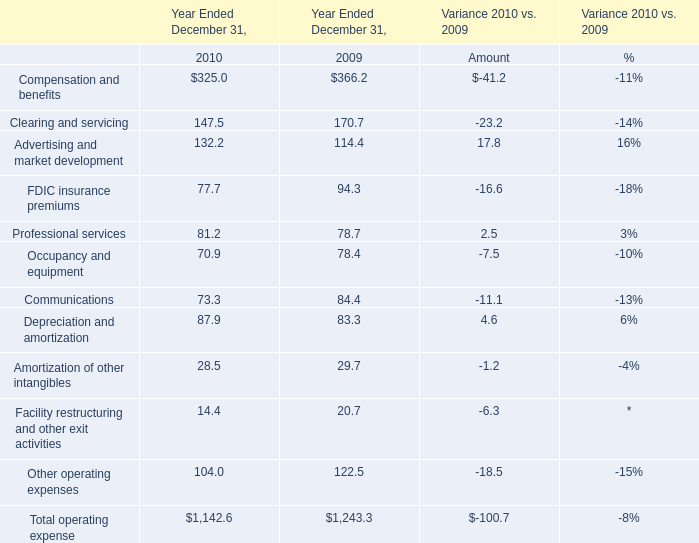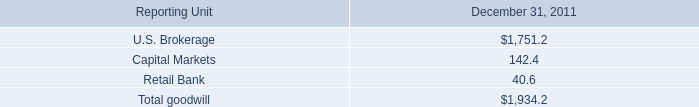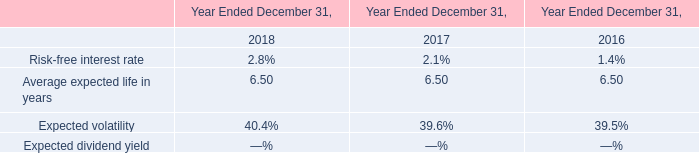What is the ratio of Compensation and benefits to the total in 2010? 
Computations: (325 / 1142.6)
Answer: 0.28444. 